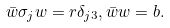Convert formula to latex. <formula><loc_0><loc_0><loc_500><loc_500>\bar { w } \sigma _ { j } w = r \delta _ { j 3 } , \bar { w } w = b .</formula> 